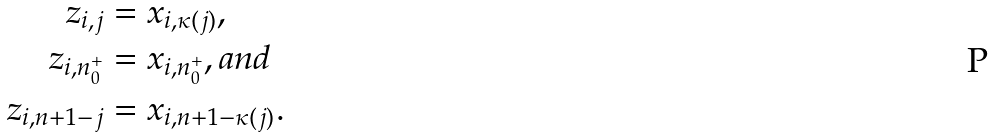<formula> <loc_0><loc_0><loc_500><loc_500>z _ { i , j } & = x _ { i , \kappa ( j ) } , \\ z _ { i , n _ { 0 } ^ { + } } & = x _ { i , n _ { 0 } ^ { + } } , a n d \\ z _ { i , n + 1 - j } & = x _ { i , n + 1 - \kappa ( j ) } .</formula> 